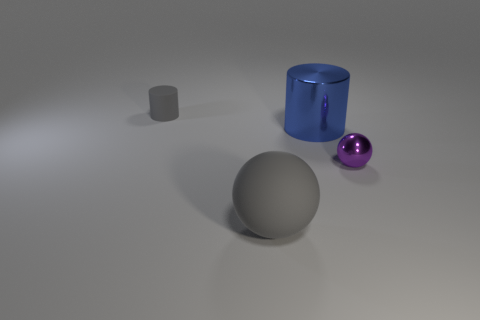There is a metal thing behind the purple metallic object that is in front of the tiny gray cylinder; how many matte balls are to the left of it?
Offer a terse response. 1. How many other objects are there of the same material as the tiny cylinder?
Keep it short and to the point. 1. There is a purple sphere that is the same size as the gray cylinder; what is its material?
Make the answer very short. Metal. Does the cylinder on the left side of the big rubber sphere have the same color as the large thing left of the blue shiny thing?
Offer a terse response. Yes. Is there a tiny gray thing that has the same shape as the blue object?
Offer a very short reply. Yes. What shape is the object that is the same size as the blue shiny cylinder?
Your answer should be very brief. Sphere. What number of objects are the same color as the big sphere?
Ensure brevity in your answer.  1. What is the size of the sphere left of the metal cylinder?
Provide a succinct answer. Large. How many objects are the same size as the blue shiny cylinder?
Your answer should be compact. 1. What color is the ball that is made of the same material as the blue object?
Give a very brief answer. Purple. 